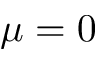<formula> <loc_0><loc_0><loc_500><loc_500>\mu = 0</formula> 